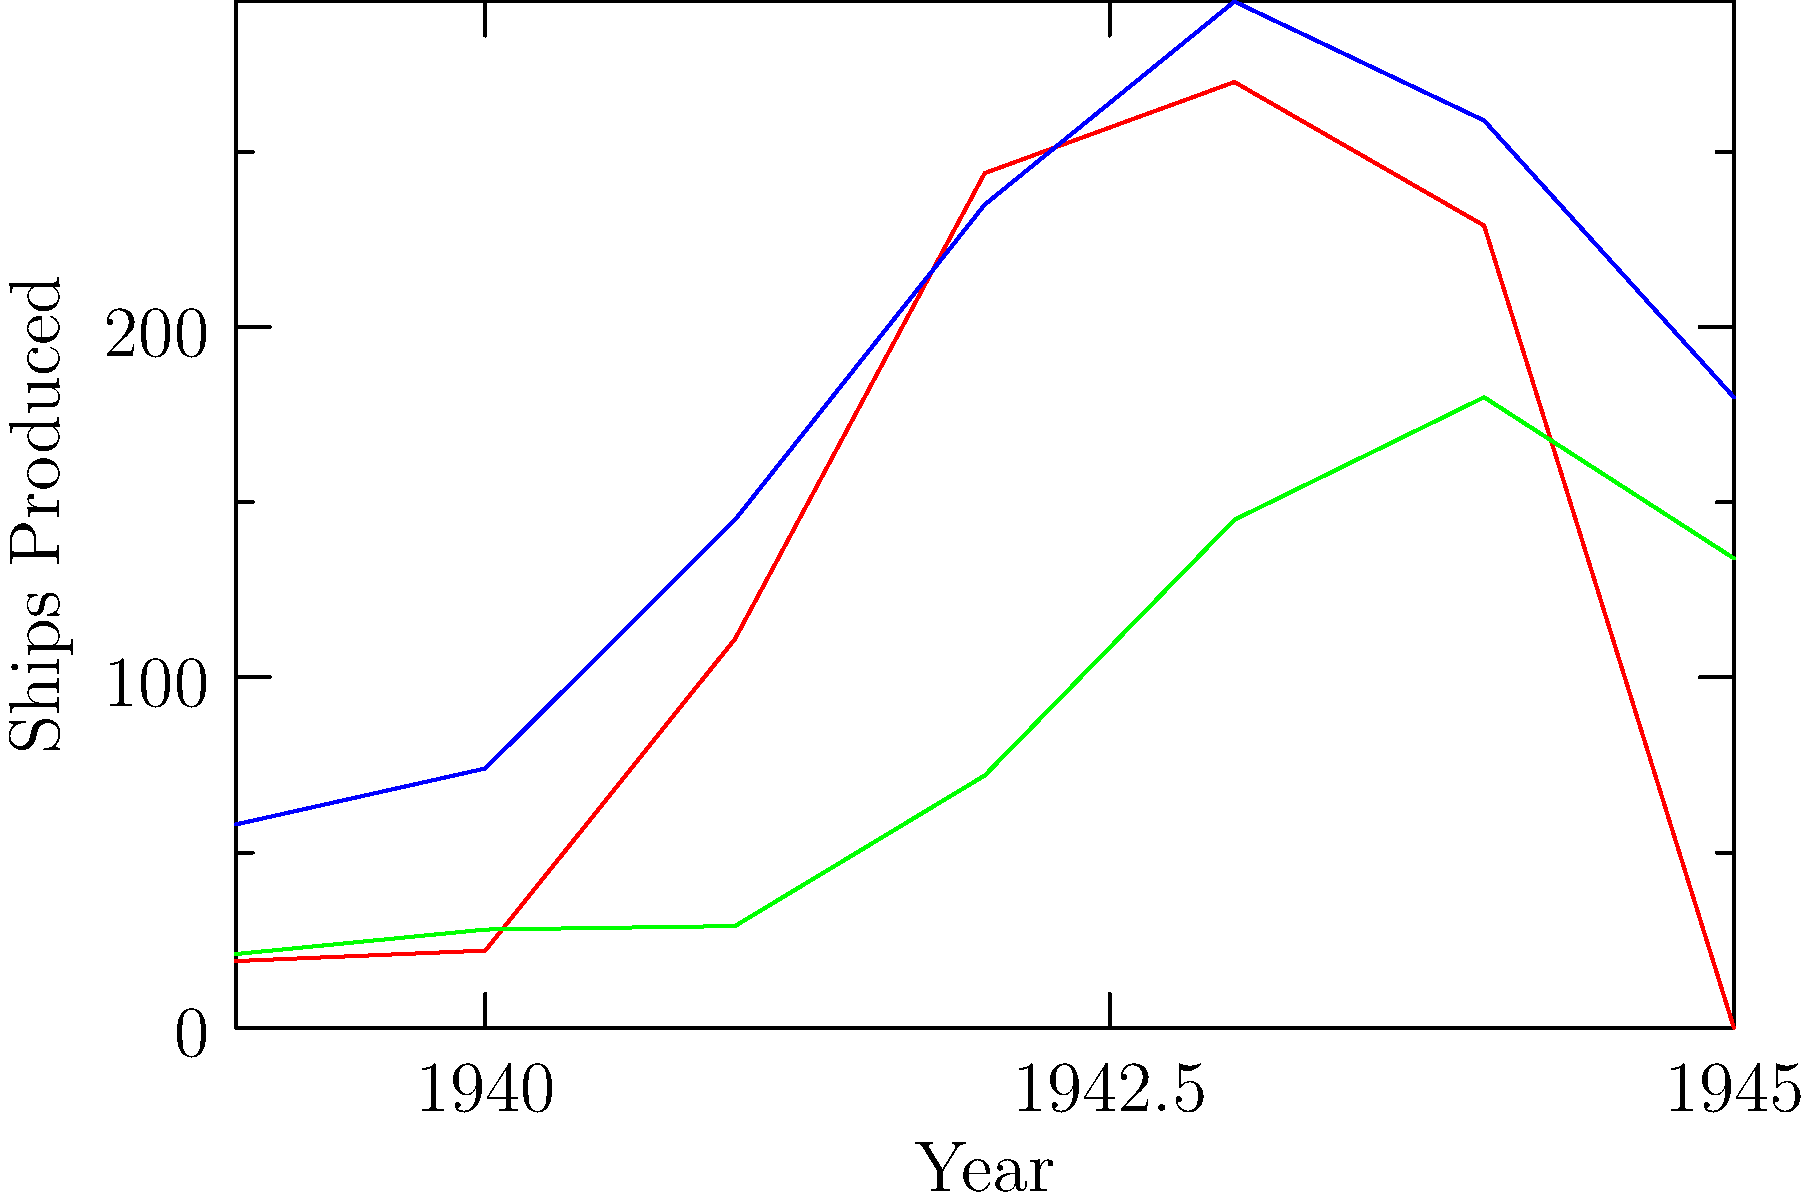Analyze the graph depicting shipbuilding output of major European powers during World War II. Which country experienced the most significant percentage increase in ship production between 1941 and 1943, and what factors might have contributed to this surge? To answer this question, we need to follow these steps:

1. Identify the production values for each country in 1941 and 1943:
   Germany: 1941 - 111, 1943 - 270
   UK: 1941 - 145, 1943 - 293
   USSR: 1941 - 29, 1943 - 145

2. Calculate the percentage increase for each country:
   Germany: $\frac{270 - 111}{111} \times 100 = 143.2\%$
   UK: $\frac{293 - 145}{145} \times 100 = 102.1\%$
   USSR: $\frac{145 - 29}{29} \times 100 = 400\%$

3. Compare the percentage increases to determine which country had the highest:
   The USSR had the highest percentage increase at 400%.

4. Consider factors that might have contributed to this surge:
   a) The USSR's relocation of industries eastward, away from the German advance
   b) Increased Soviet industrial capacity due to Lend-Lease aid from the Allies
   c) The urgent need for ships to maintain supply lines across the Arctic and Pacific
   d) Recovery and expansion of shipbuilding capabilities after initial war losses
   e) Mobilization of the Soviet workforce, including women, in war industries

The USSR's dramatic increase in ship production reflects its rapid industrialization and the desperate need to replace losses from the early stages of the war, particularly following Operation Barbarossa in 1941.
Answer: USSR (400% increase); factors include industrial relocation, Lend-Lease aid, urgent need for supply ships, and workforce mobilization. 